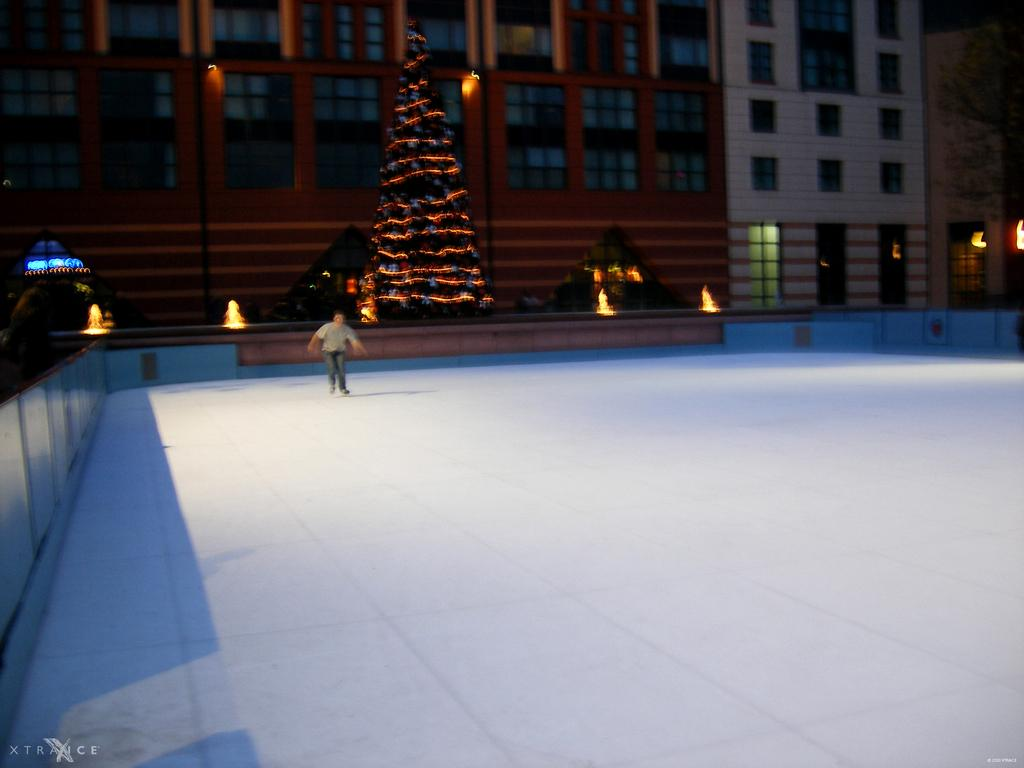What type of structures can be seen in the image? There are buildings in the image. What architectural feature is visible in the buildings? There are windows in the image. What type of decorative element is present in the image? There are fountains in the image. What seasonal decoration is featured in the image? There is a Christmas tree in the image. What type of illumination is present in the image? There are lights in the image. Are there any people present in the image? Yes, there is a person in the image. What type of detail can be seen on the scarecrow in the image? There is no scarecrow present in the image. How many light bulbs are visible on the light in the image? The image does not provide a specific count of light bulbs on the light. 